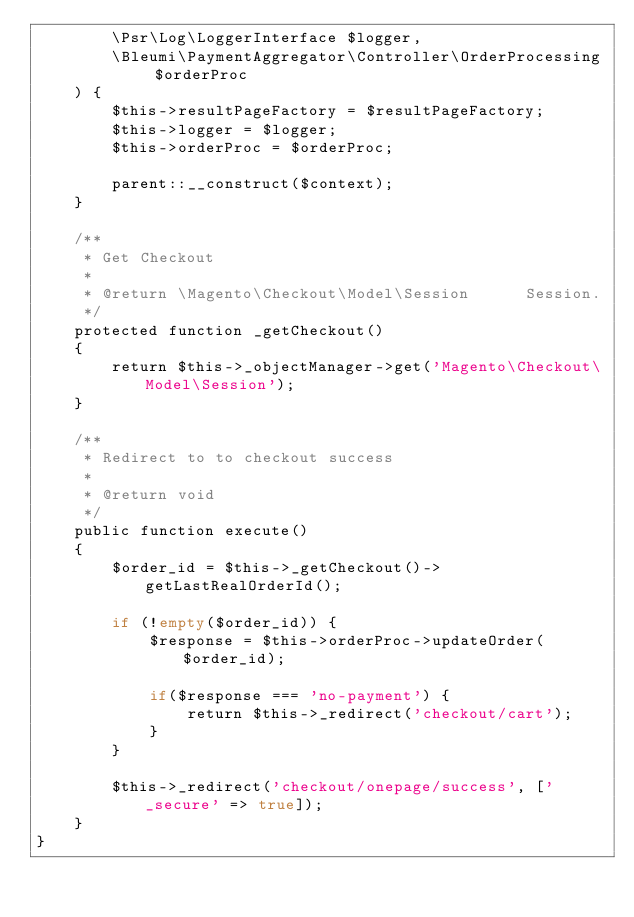Convert code to text. <code><loc_0><loc_0><loc_500><loc_500><_PHP_>        \Psr\Log\LoggerInterface $logger,
        \Bleumi\PaymentAggregator\Controller\OrderProcessing $orderProc
    ) {
        $this->resultPageFactory = $resultPageFactory;
        $this->logger = $logger;
        $this->orderProc = $orderProc;
        
        parent::__construct($context);
    }

    /**
     * Get Checkout
     *
     * @return \Magento\Checkout\Model\Session      Session.
     */
    protected function _getCheckout()
    {
        return $this->_objectManager->get('Magento\Checkout\Model\Session');
    }

    /**
     * Redirect to to checkout success
     *
     * @return void
     */
    public function execute()
    {
        $order_id = $this->_getCheckout()->getLastRealOrderId();

        if (!empty($order_id)) {
            $response = $this->orderProc->updateOrder($order_id);
            
            if($response === 'no-payment') {
                return $this->_redirect('checkout/cart');
            }
        }

        $this->_redirect('checkout/onepage/success', ['_secure' => true]);
    }
}
</code> 